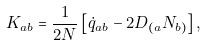<formula> <loc_0><loc_0><loc_500><loc_500>K _ { a b } = \frac { 1 } { 2 N } \left [ \dot { q } _ { a b } - 2 D _ { ( a } N _ { b ) } \right ] ,</formula> 